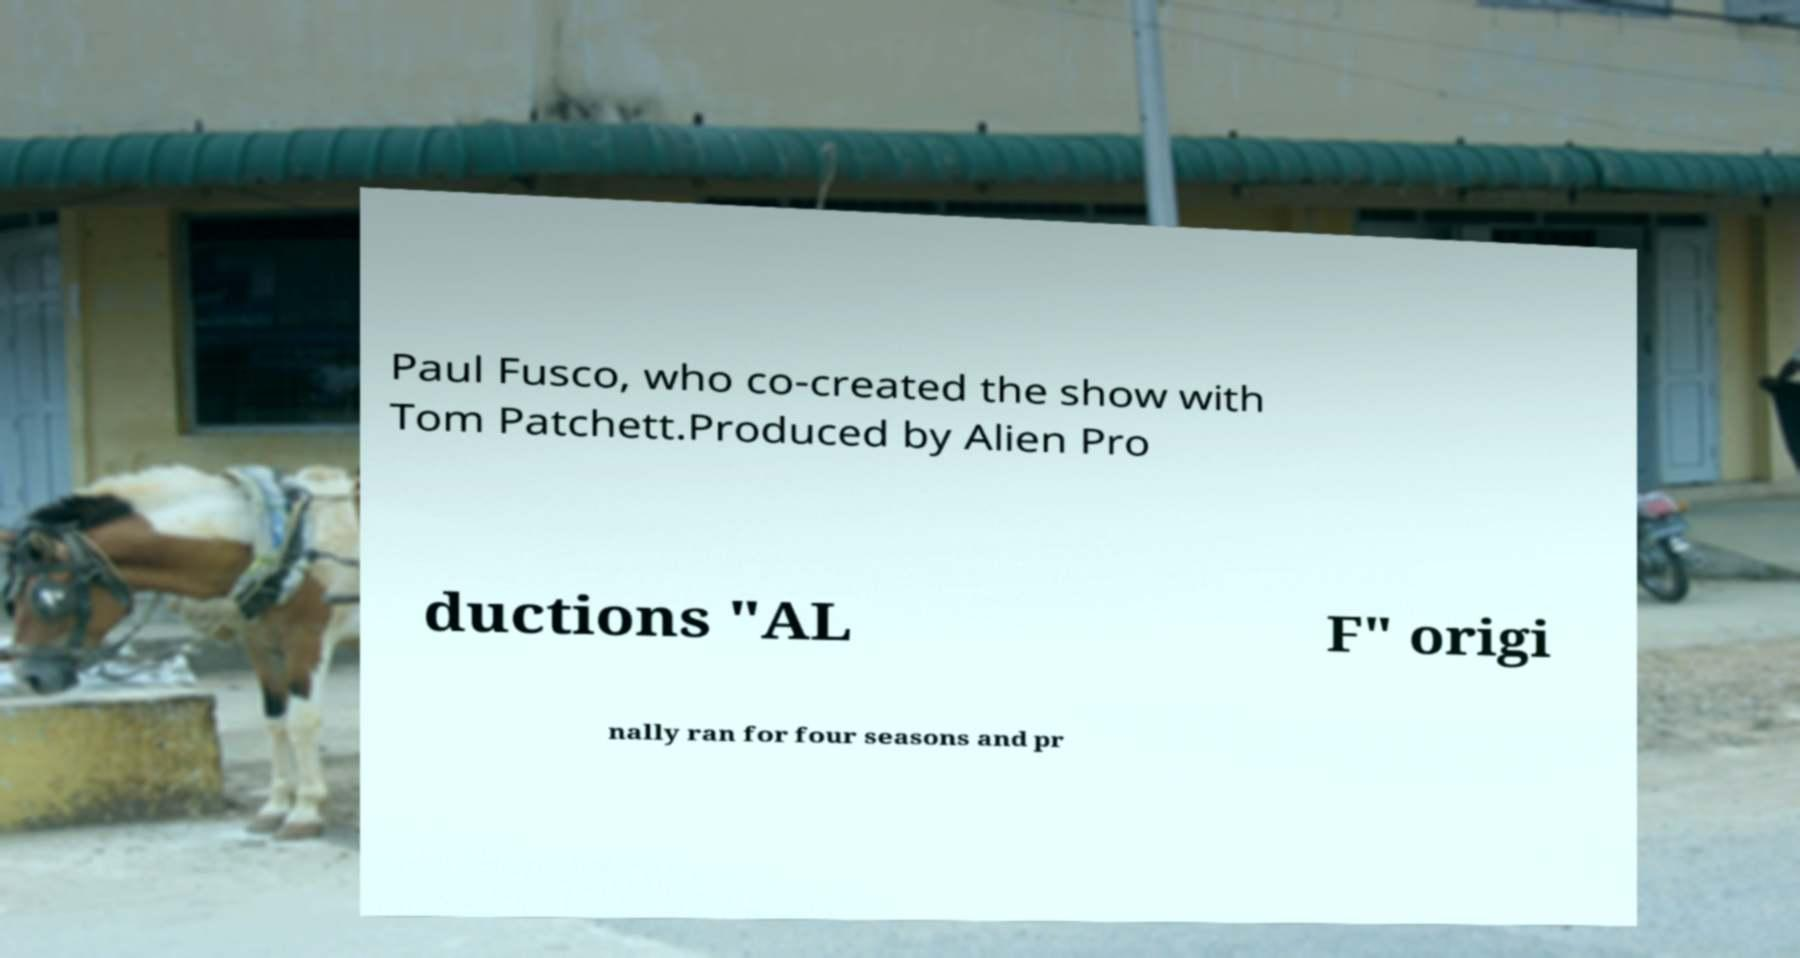What messages or text are displayed in this image? I need them in a readable, typed format. Paul Fusco, who co-created the show with Tom Patchett.Produced by Alien Pro ductions "AL F" origi nally ran for four seasons and pr 